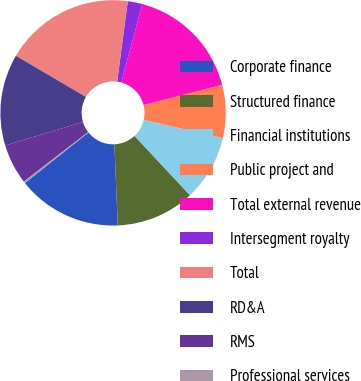Convert chart. <chart><loc_0><loc_0><loc_500><loc_500><pie_chart><fcel>Corporate finance<fcel>Structured finance<fcel>Financial institutions<fcel>Public project and<fcel>Total external revenue<fcel>Intersegment royalty<fcel>Total<fcel>RD&A<fcel>RMS<fcel>Professional services<nl><fcel>14.96%<fcel>11.29%<fcel>9.45%<fcel>7.61%<fcel>16.8%<fcel>2.1%<fcel>18.63%<fcel>13.12%<fcel>5.77%<fcel>0.26%<nl></chart> 